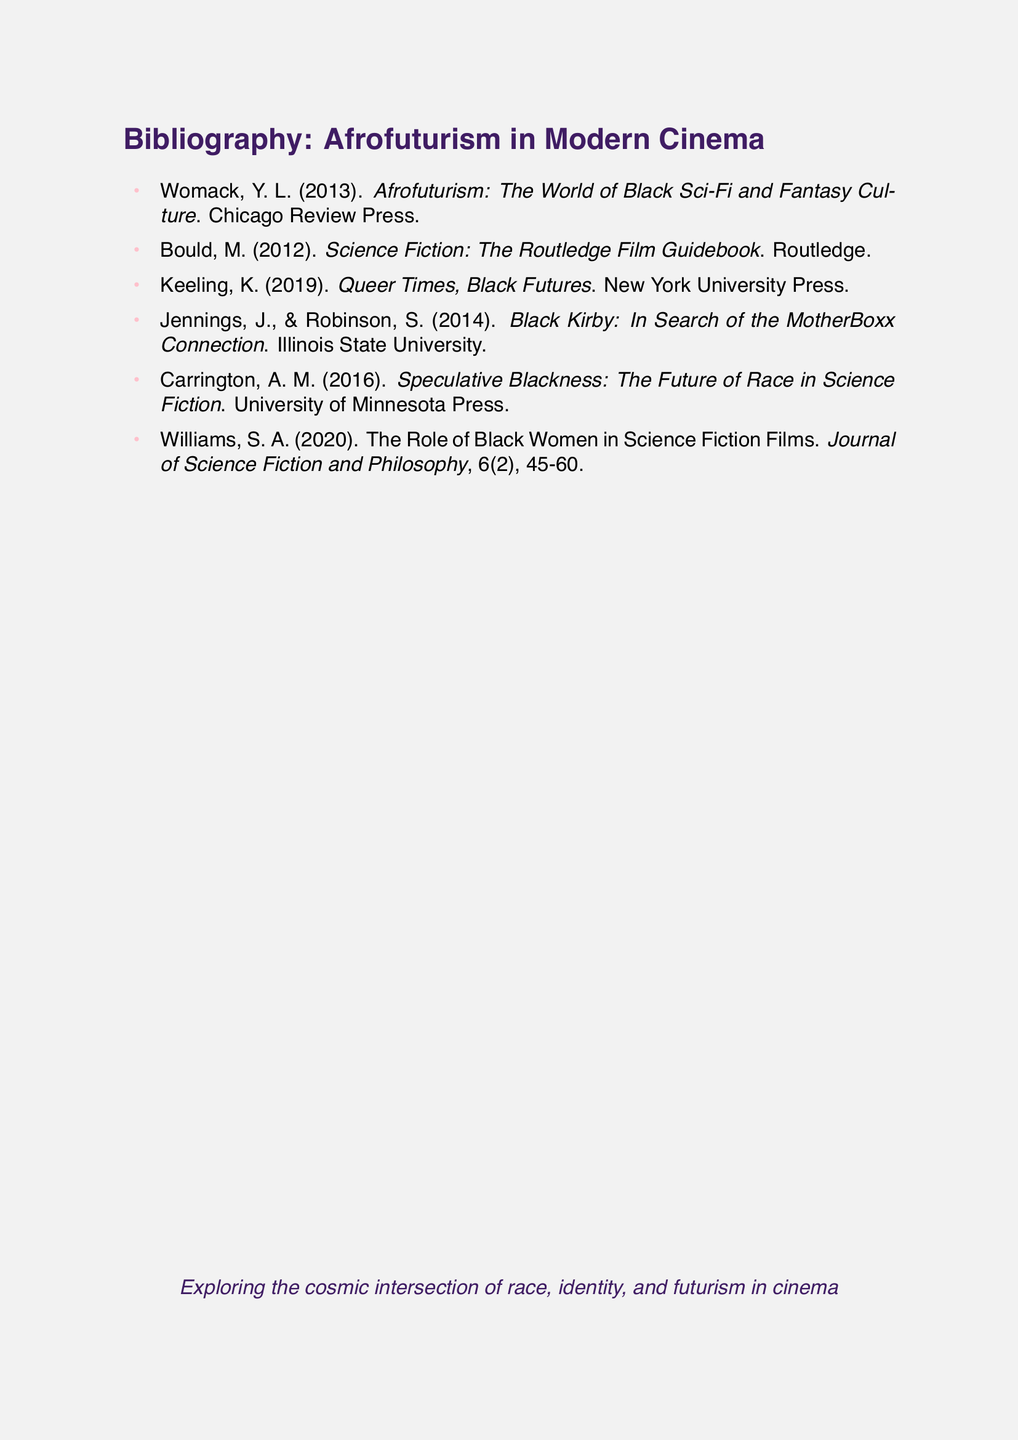What is the title of Womack's book? Womack's book's title is listed in the bibliography, which is "Afrofuturism: The World of Black Sci-Fi and Fantasy Culture".
Answer: Afrofuturism: The World of Black Sci-Fi and Fantasy Culture Who published "Queer Times, Black Futures"? The publisher of "Queer Times, Black Futures" is New York University Press, as noted in the bibliography.
Answer: New York University Press How many authors contributed to "Black Kirby: In Search of the MotherBoxx Connection"? The bibliography indicates that there are two authors for this work, Jennings and Robinson.
Answer: 2 In what year was "Speculative Blackness: The Future of Race in Science Fiction" published? The document specifies that it was published in 2016, making it easy to find the year.
Answer: 2016 What is the focus of the article by Williams? The document describes that Williams' article discusses the role of Black women in a specific genre, which is science fiction films.
Answer: Science Fiction Films What is the overall theme of the bibliography? The document states that it explores "the cosmic intersection of race, identity, and futurism in cinema," which gives insight into the main theme.
Answer: The cosmic intersection of race, identity, and futurism in cinema Who is the author of the book published by Routledge? The bibliography lists the author of the Routledge publication as Bould.
Answer: Bould 